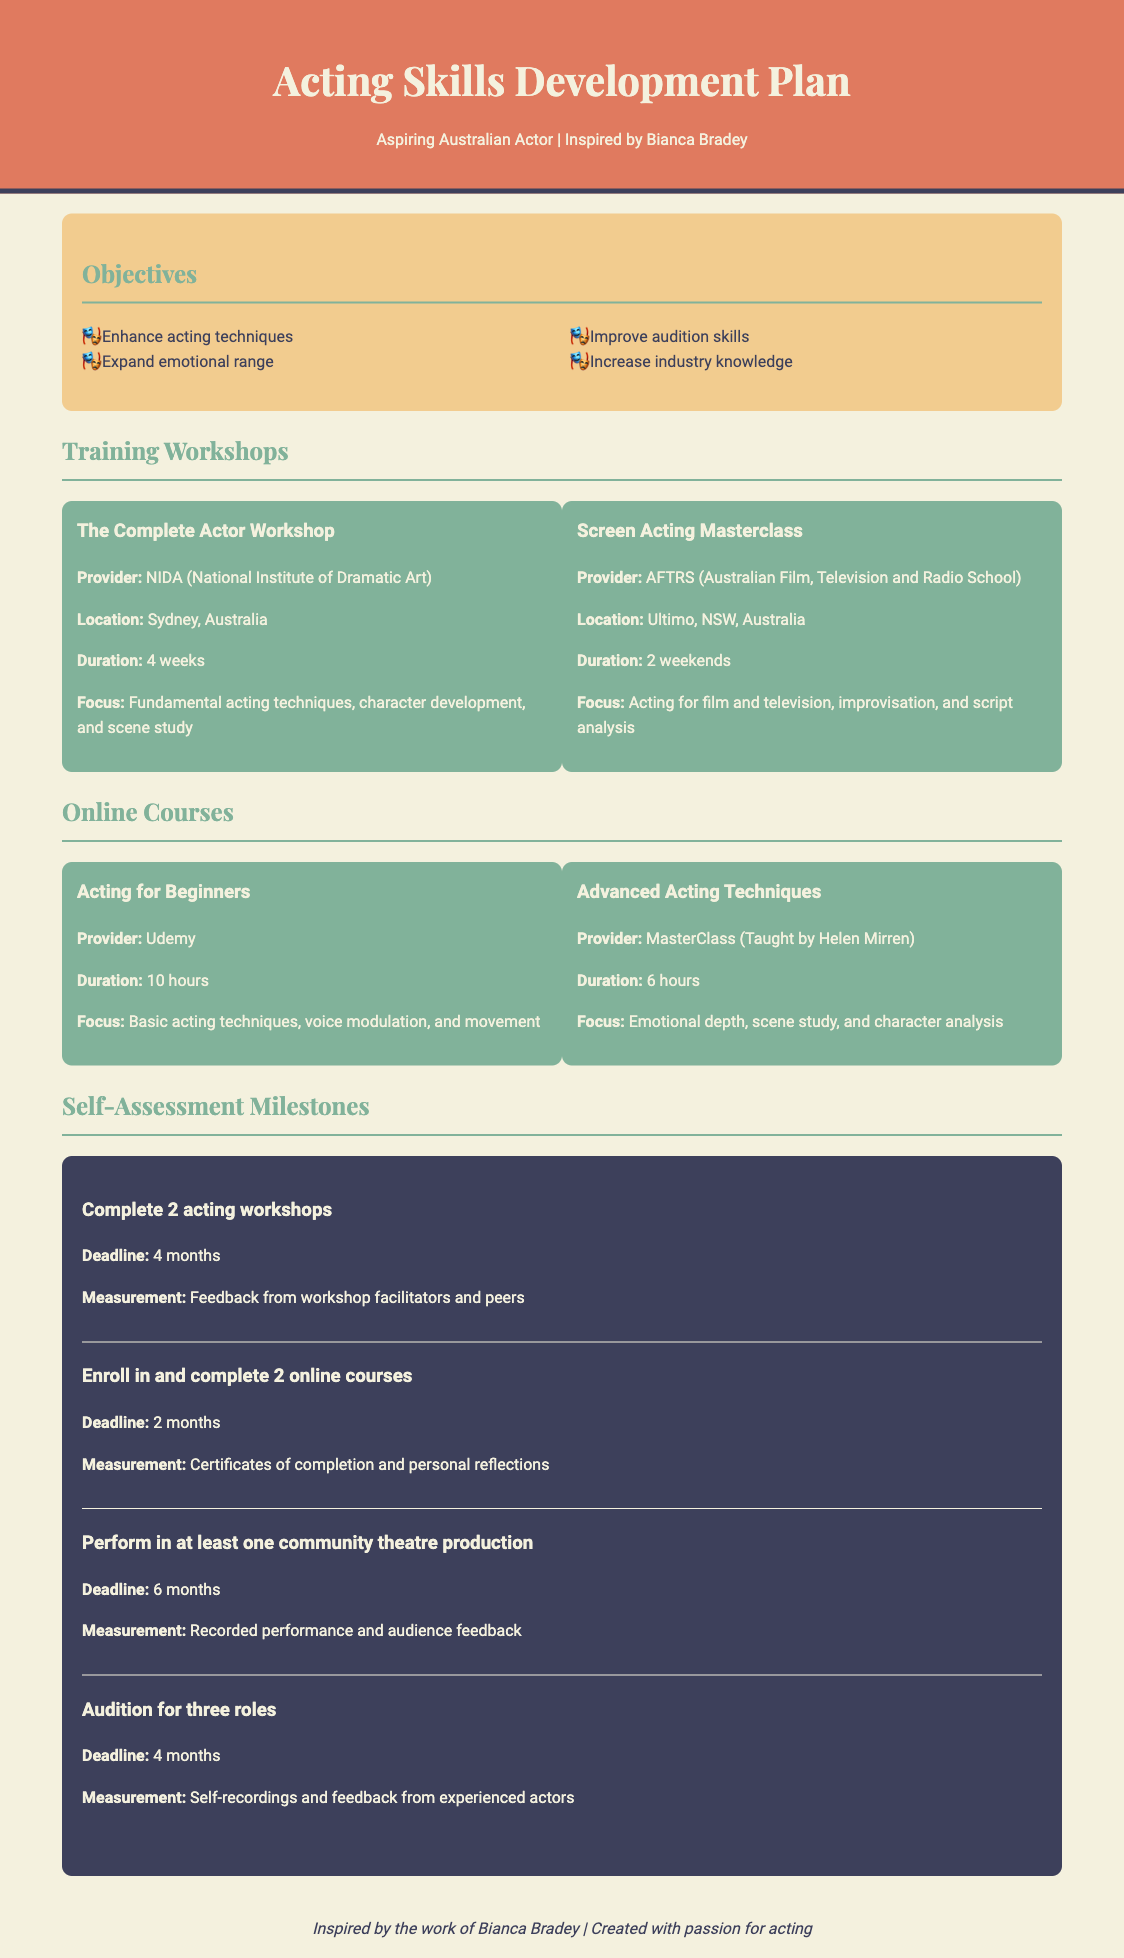What are the objectives of the development plan? The objectives are listed in the document, which focuses on enhancing acting techniques, expanding emotional range, improving audition skills, and increasing industry knowledge.
Answer: Enhance acting techniques, expand emotional range, improve audition skills, increase industry knowledge What is the location of "The Complete Actor Workshop"? The document specifies that "The Complete Actor Workshop" is provided by NIDA in Sydney, Australia.
Answer: Sydney, Australia How many weeks does the "Screen Acting Masterclass" last? The training information details that the "Screen Acting Masterclass" lasts for 2 weekends, which totals approximately 4 days or 1 week.
Answer: 2 weekends What is the duration of the "Advanced Acting Techniques" course? The document states that the "Advanced Acting Techniques" online course has a duration of 6 hours.
Answer: 6 hours What is the focus of the "Acting for Beginners" course? The document outlines that the focus of the "Acting for Beginners" course involves basic acting techniques, voice modulation, and movement.
Answer: Basic acting techniques, voice modulation, and movement What is the deadline to complete 2 online courses? The self-assessment milestones section mentions that the deadline for completing 2 online courses is set for 2 months.
Answer: 2 months How many roles should be auditioned for according to the plan? The document indicates that the goal is to audition for three roles.
Answer: Three roles Which provider teaches the "Advanced Acting Techniques" course? The document identifies MasterClass, taught by Helen Mirren, as the provider of the "Advanced Acting Techniques" course.
Answer: MasterClass (Taught by Helen Mirren) 